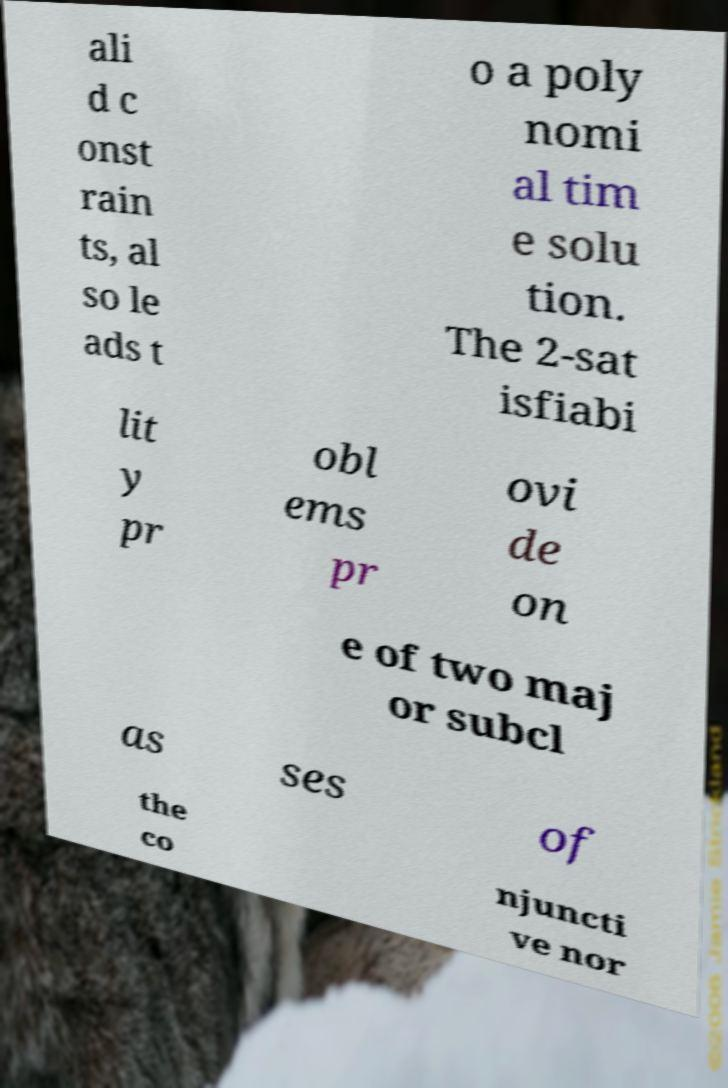I need the written content from this picture converted into text. Can you do that? ali d c onst rain ts, al so le ads t o a poly nomi al tim e solu tion. The 2-sat isfiabi lit y pr obl ems pr ovi de on e of two maj or subcl as ses of the co njuncti ve nor 